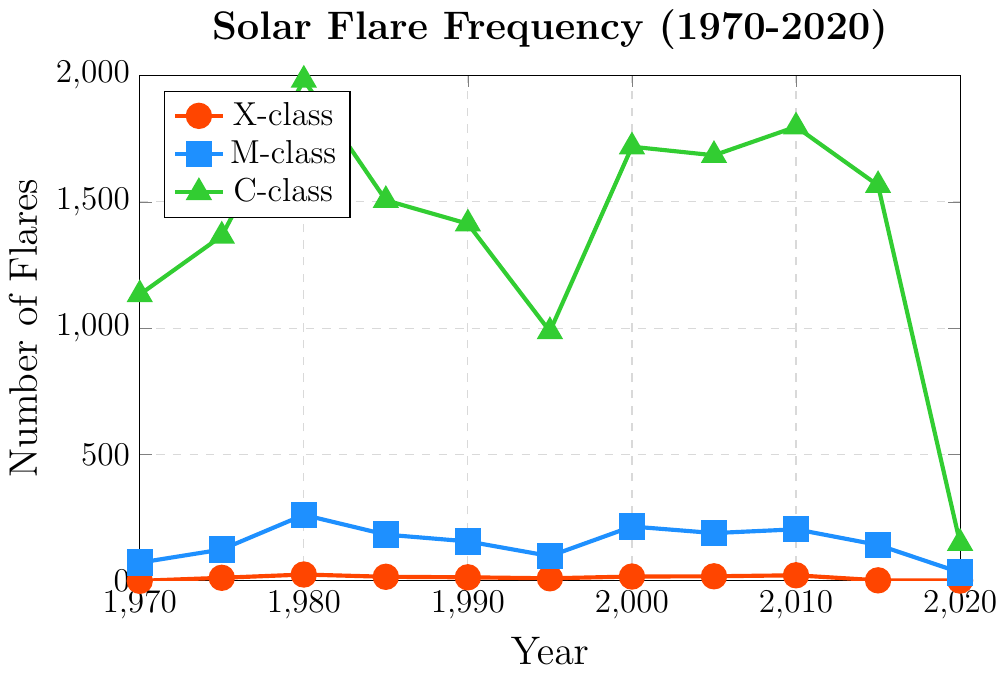What's the highest frequency of C-class flares, and which year did it occur? The highest point on the C-class plot represents the peak frequency. This peak occurs at the year 1980.
Answer: 1980, 1982 Compare the frequency of M-class and X-class flares in the year 2000. Which one was higher and by how much? Looking at the points on the plot for the year 2000, the frequency of M-class flares is 215, and for X-class flares, it’s 17. The frequency of M-class flares is higher by 215 - 17 = 198.
Answer: M-class by 198 Between which two consecutive five-year periods did the frequency of X-class flares increase the most? Checking the plot points for X-class flares, the increase from 1975 to 1980 is 25 - 12 = 13, 1995 to 2000 is 17 - 10 = 7, and 2000 to 2005 is 18 - 17 = 1. The largest increase is between 1975 and 1980.
Answer: 1975-1980 What is the average frequency of M-class flares from 1970 to 2020? Summing up the frequencies for M-class flares (72, 124, 261, etc.) and dividing by the number of data points (11) results in (72 + 124 + 261 + 183 + 156 + 98 + 215 + 189 + 204 + 142 + 33) / 11, which equals approximately 144.
Answer: 144 In which year did the frequency of X-class flares first exceed 20? Observing the X-class plot, the first year where frequency exceeds 20 is 2010.
Answer: 2010 Between the years 1980 and 1995, how did the frequencies of C-class flares change overall? Examining the plot for C-class flares from 1980 (1982) to 1995 (987), there is an overall decrease of 1982 - 987 = 995.
Answer: Decreased by 995 How many years had fewer than 100 M-class flares? Checking the M-class plot, years 1970 (72), 1995 (98), and 2020 (33) fall below 100.
Answer: 3 years What is the trend of X-class flares from 2010 to 2020? Observing the plot for X-class flares from 2010 (22) to 2020 (1), it shows a decreasing trend.
Answer: Decreasing What is the difference in C-class flare frequency between the highest and lowest years? The highest frequency for C-class flares is 1982 in 1980, and the lowest is 149 in 2020. The difference is 1982 - 149 = 1833.
Answer: 1833 Which flare class shows the most variability in frequency over the 50-year period? By observing the plot, C-class flares exhibit the highest variability, ranging from 1133 to 1982 (a range of 849), compared to smaller ranges for X-class and M-class flares.
Answer: C-class 